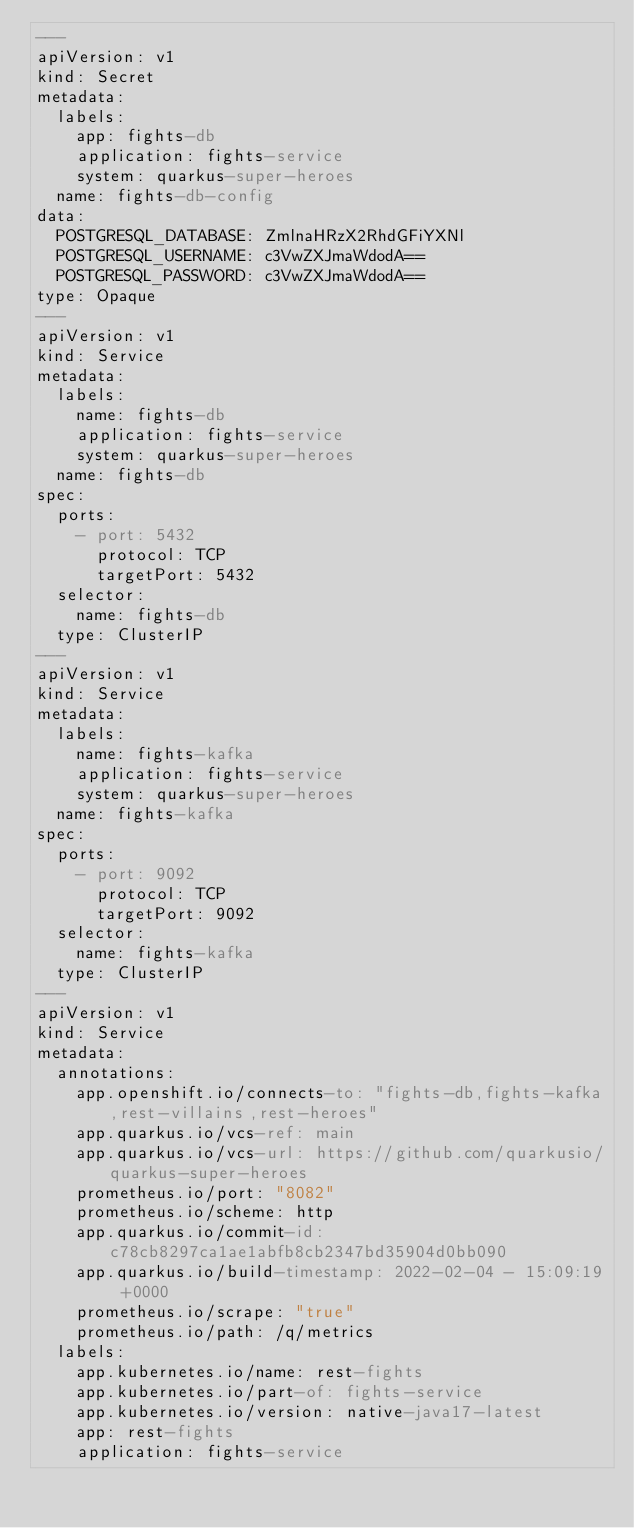Convert code to text. <code><loc_0><loc_0><loc_500><loc_500><_YAML_>---
apiVersion: v1
kind: Secret
metadata:
  labels:
    app: fights-db
    application: fights-service
    system: quarkus-super-heroes
  name: fights-db-config
data:
  POSTGRESQL_DATABASE: ZmlnaHRzX2RhdGFiYXNl
  POSTGRESQL_USERNAME: c3VwZXJmaWdodA==
  POSTGRESQL_PASSWORD: c3VwZXJmaWdodA==
type: Opaque
---
apiVersion: v1
kind: Service
metadata:
  labels:
    name: fights-db
    application: fights-service
    system: quarkus-super-heroes
  name: fights-db
spec:
  ports:
    - port: 5432
      protocol: TCP
      targetPort: 5432
  selector:
    name: fights-db
  type: ClusterIP
---
apiVersion: v1
kind: Service
metadata:
  labels:
    name: fights-kafka
    application: fights-service
    system: quarkus-super-heroes
  name: fights-kafka
spec:
  ports:
    - port: 9092
      protocol: TCP
      targetPort: 9092
  selector:
    name: fights-kafka
  type: ClusterIP
---
apiVersion: v1
kind: Service
metadata:
  annotations:
    app.openshift.io/connects-to: "fights-db,fights-kafka,rest-villains,rest-heroes"
    app.quarkus.io/vcs-ref: main
    app.quarkus.io/vcs-url: https://github.com/quarkusio/quarkus-super-heroes
    prometheus.io/port: "8082"
    prometheus.io/scheme: http
    app.quarkus.io/commit-id: c78cb8297ca1ae1abfb8cb2347bd35904d0bb090
    app.quarkus.io/build-timestamp: 2022-02-04 - 15:09:19 +0000
    prometheus.io/scrape: "true"
    prometheus.io/path: /q/metrics
  labels:
    app.kubernetes.io/name: rest-fights
    app.kubernetes.io/part-of: fights-service
    app.kubernetes.io/version: native-java17-latest
    app: rest-fights
    application: fights-service</code> 